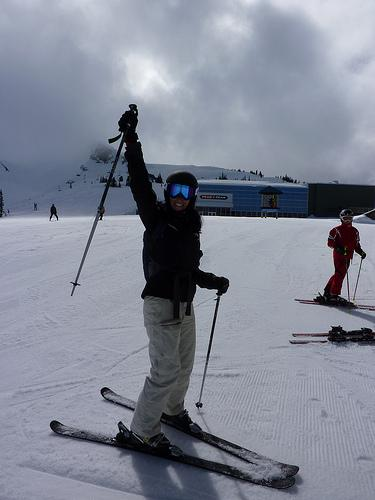Question: how many are skiing?
Choices:
A. Two.
B. Four.
C. Six.
D. Three.
Answer with the letter. Answer: D Question: who wearing the jacket?
Choices:
A. A woman.
B. The skier.
C. The cild.
D. The busdriver.
Answer with the letter. Answer: A Question: why the woman is wearing jacket?
Choices:
A. To protect from the rain.
B. It's cold.
C. It is fashionable.
D. It is windy out.
Answer with the letter. Answer: B Question: what is the color of the goggles?
Choices:
A. Blue.
B. Yellow.
C. Pink.
D. White.
Answer with the letter. Answer: A Question: where is the goggles?
Choices:
A. A woman is wearing it.
B. On the man's head.
C. On the table.
D. In the store.
Answer with the letter. Answer: A 